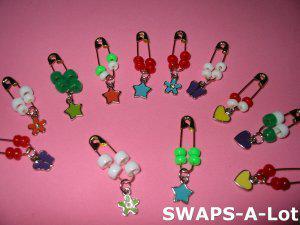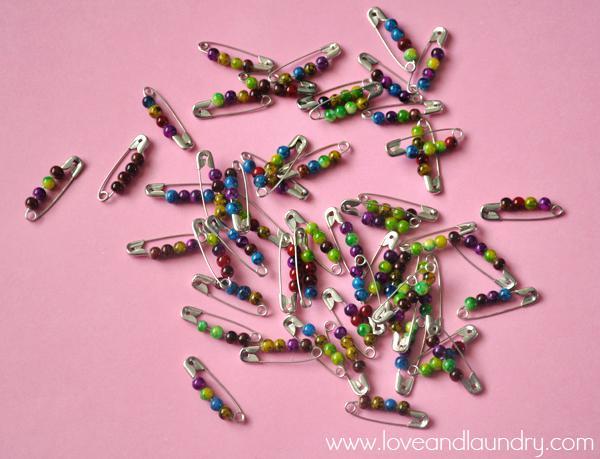The first image is the image on the left, the second image is the image on the right. For the images displayed, is the sentence "The left image has four safety pins." factually correct? Answer yes or no. No. The first image is the image on the left, the second image is the image on the right. For the images shown, is this caption "An image shows exactly six safety pins strung with beads, displayed on purple." true? Answer yes or no. No. 